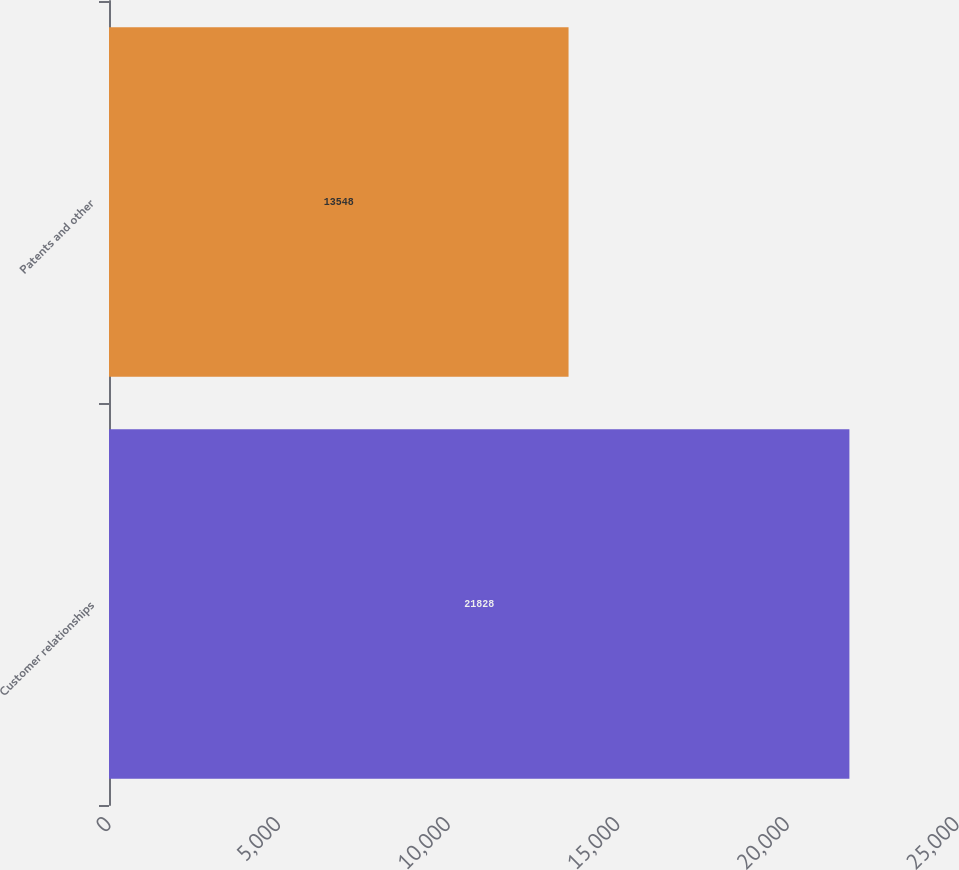Convert chart. <chart><loc_0><loc_0><loc_500><loc_500><bar_chart><fcel>Customer relationships<fcel>Patents and other<nl><fcel>21828<fcel>13548<nl></chart> 